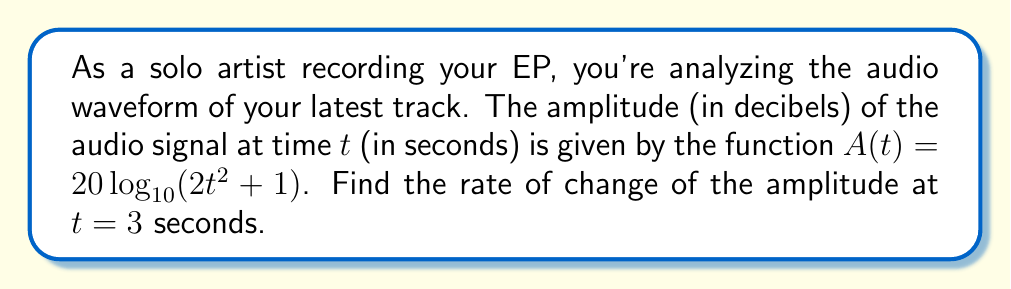Teach me how to tackle this problem. To find the rate of change of the amplitude at t = 3 seconds, we need to calculate the derivative of the function A(t) and evaluate it at t = 3.

Step 1: Calculate the derivative of A(t)
$$\frac{d}{dt}A(t) = \frac{d}{dt}[20\log_{10}(2t^2 + 1)]$$

Using the chain rule:
$$\frac{d}{dt}A(t) = 20 \cdot \frac{1}{2t^2 + 1} \cdot \frac{d}{dt}(2t^2 + 1) \cdot \frac{1}{\ln(10)}$$

$$\frac{d}{dt}A(t) = 20 \cdot \frac{1}{2t^2 + 1} \cdot 4t \cdot \frac{1}{\ln(10)}$$

$$\frac{d}{dt}A(t) = \frac{80t}{(2t^2 + 1)\ln(10)}$$

Step 2: Evaluate the derivative at t = 3
$$\frac{d}{dt}A(3) = \frac{80(3)}{(2(3)^2 + 1)\ln(10)}$$

$$\frac{d}{dt}A(3) = \frac{240}{(18 + 1)\ln(10)} = \frac{240}{19\ln(10)}$$

Step 3: Simplify the result
$$\frac{d}{dt}A(3) \approx 5.49 \text{ dB/s}$$
Answer: $5.49 \text{ dB/s}$ 